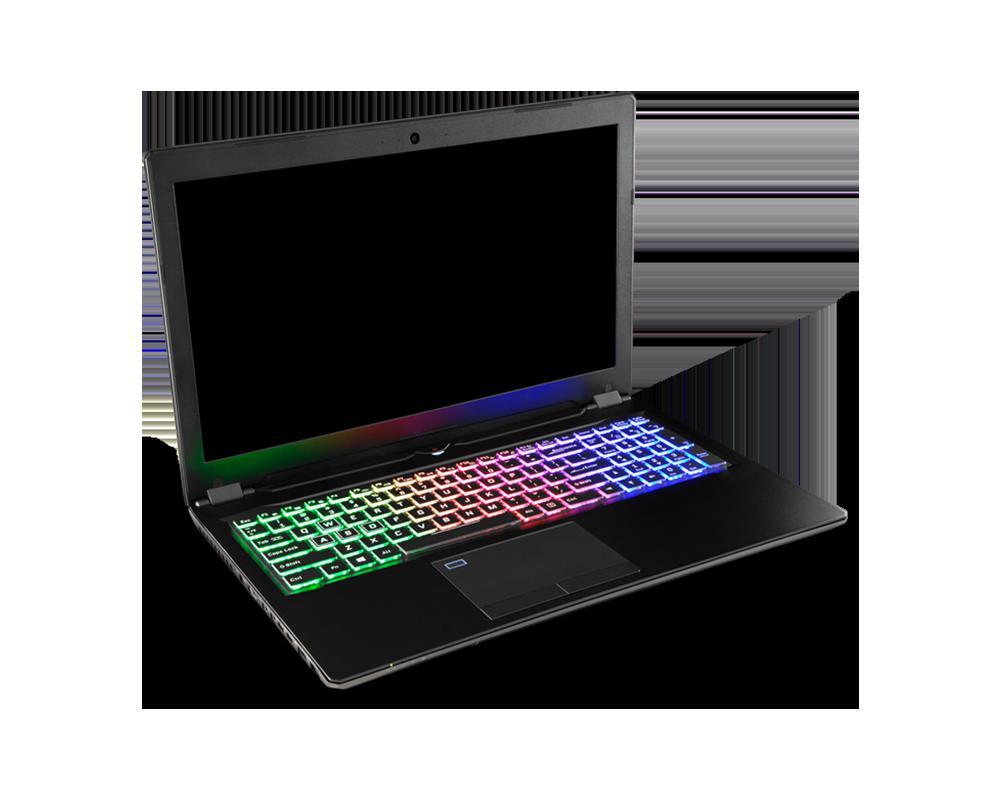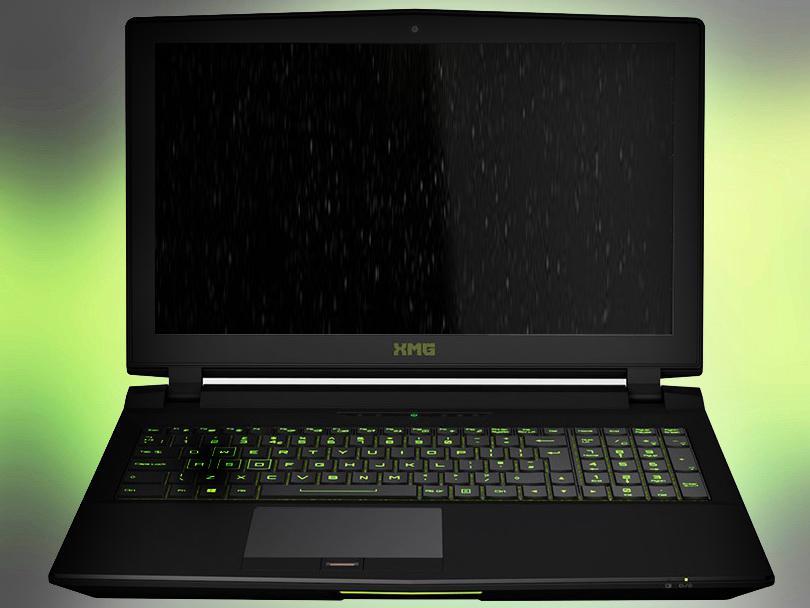The first image is the image on the left, the second image is the image on the right. For the images displayed, is the sentence "there is a laptop with rainbow colored lit up kets and a lit up light in front of the laptops base" factually correct? Answer yes or no. No. The first image is the image on the left, the second image is the image on the right. Examine the images to the left and right. Is the description "One image shows an open laptop viewed head-on and screen-first, and the other image shows an open laptop with a black screen displayed at an angle." accurate? Answer yes or no. Yes. 